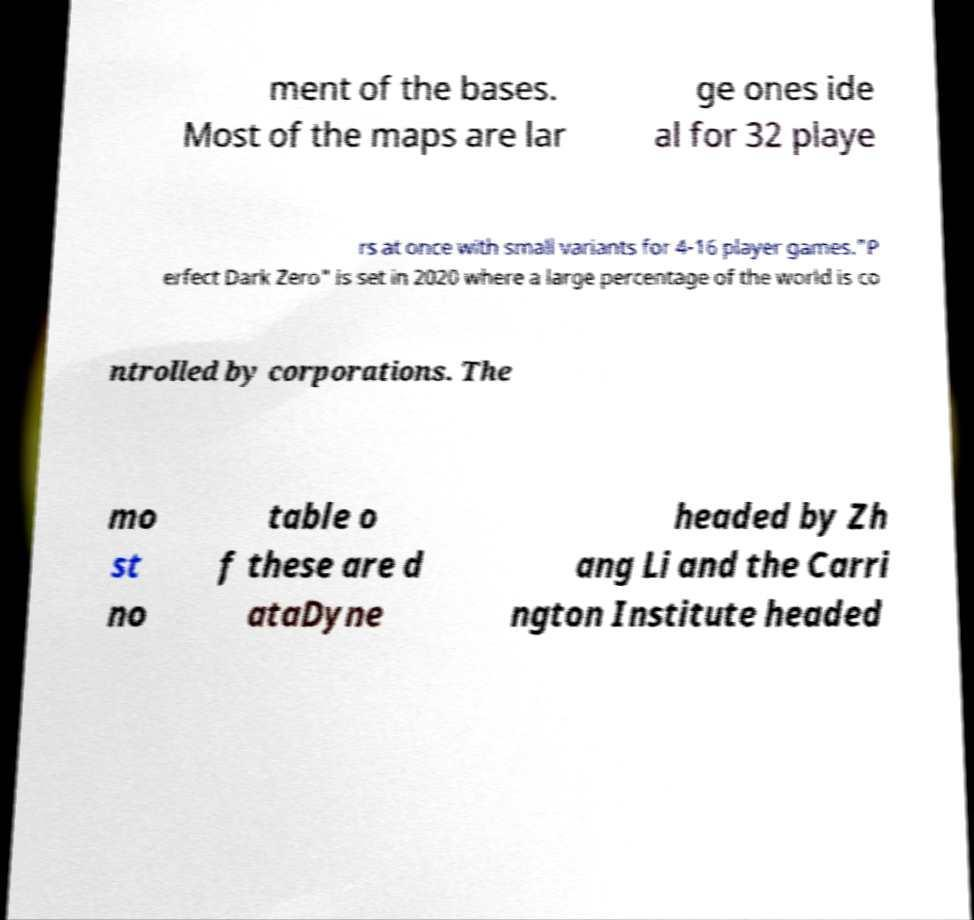For documentation purposes, I need the text within this image transcribed. Could you provide that? ment of the bases. Most of the maps are lar ge ones ide al for 32 playe rs at once with small variants for 4-16 player games."P erfect Dark Zero" is set in 2020 where a large percentage of the world is co ntrolled by corporations. The mo st no table o f these are d ataDyne headed by Zh ang Li and the Carri ngton Institute headed 